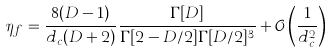Convert formula to latex. <formula><loc_0><loc_0><loc_500><loc_500>\eta _ { f } = \frac { 8 ( D - 1 ) } { d _ { c } ( D + 2 ) } \frac { \Gamma [ D ] } { \Gamma [ 2 - D / 2 ] \Gamma [ D / 2 ] ^ { 3 } } + \mathcal { O } \left ( \frac { 1 } { d _ { c } ^ { 2 } } \right )</formula> 